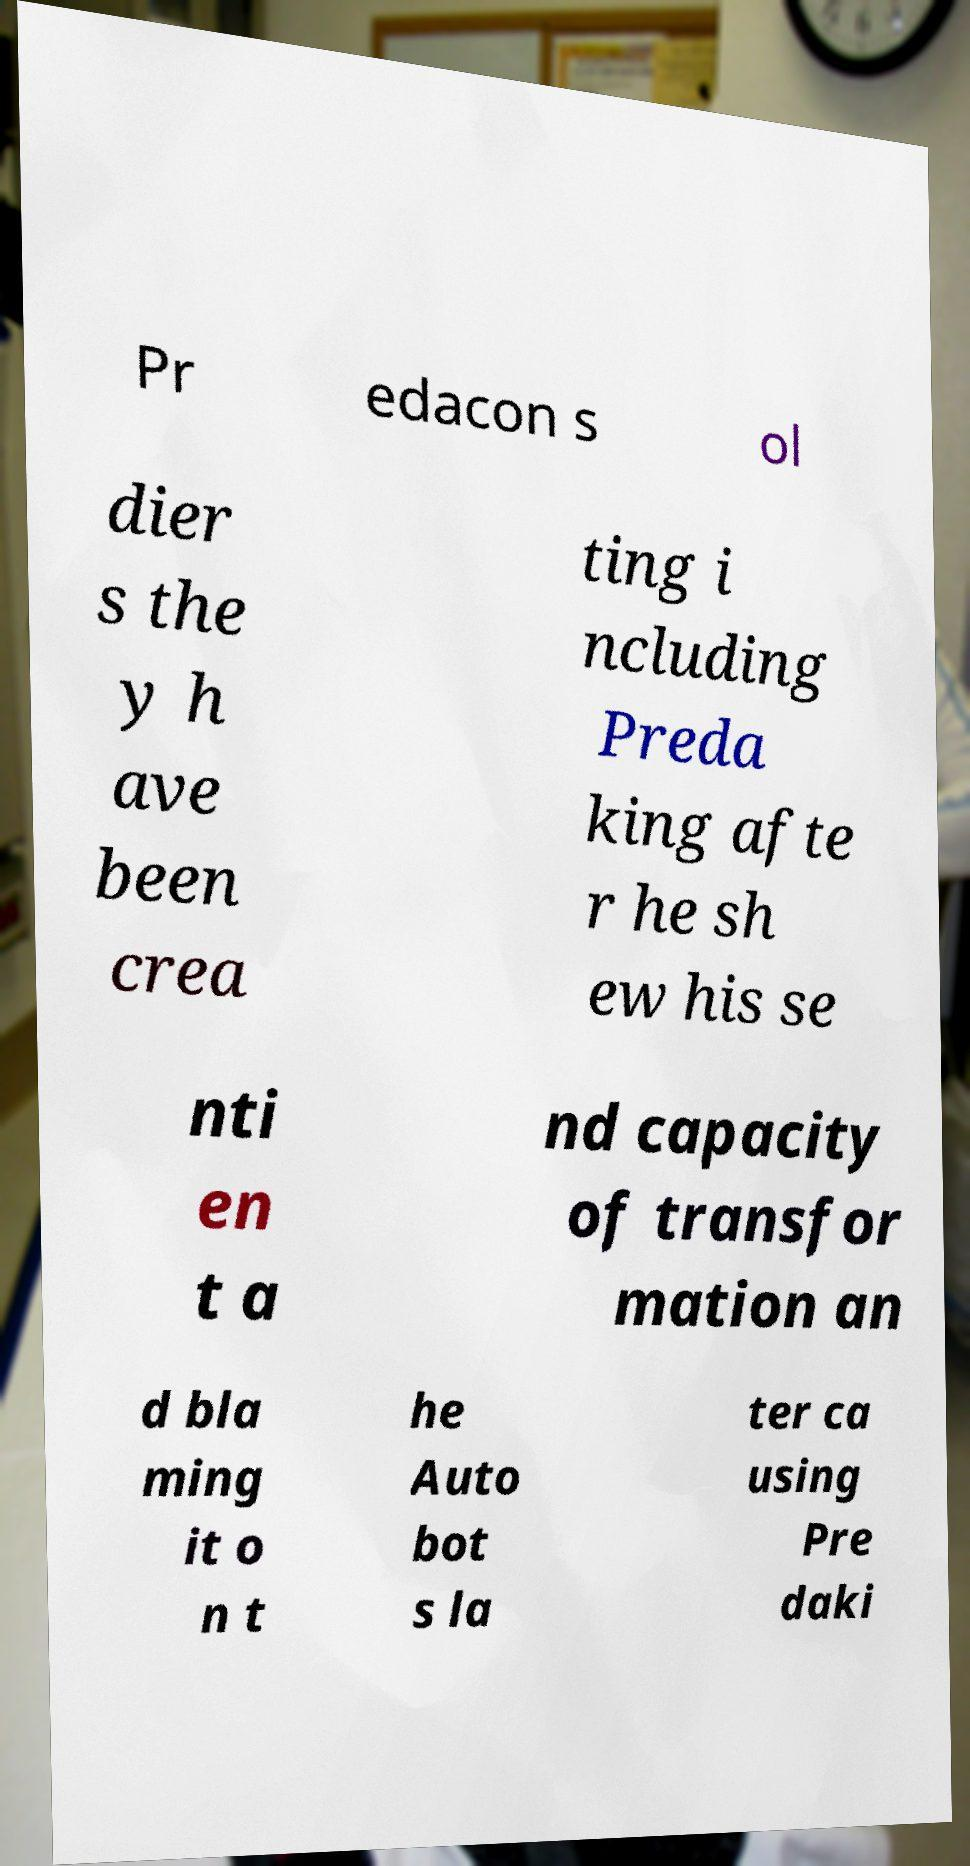Please identify and transcribe the text found in this image. Pr edacon s ol dier s the y h ave been crea ting i ncluding Preda king afte r he sh ew his se nti en t a nd capacity of transfor mation an d bla ming it o n t he Auto bot s la ter ca using Pre daki 